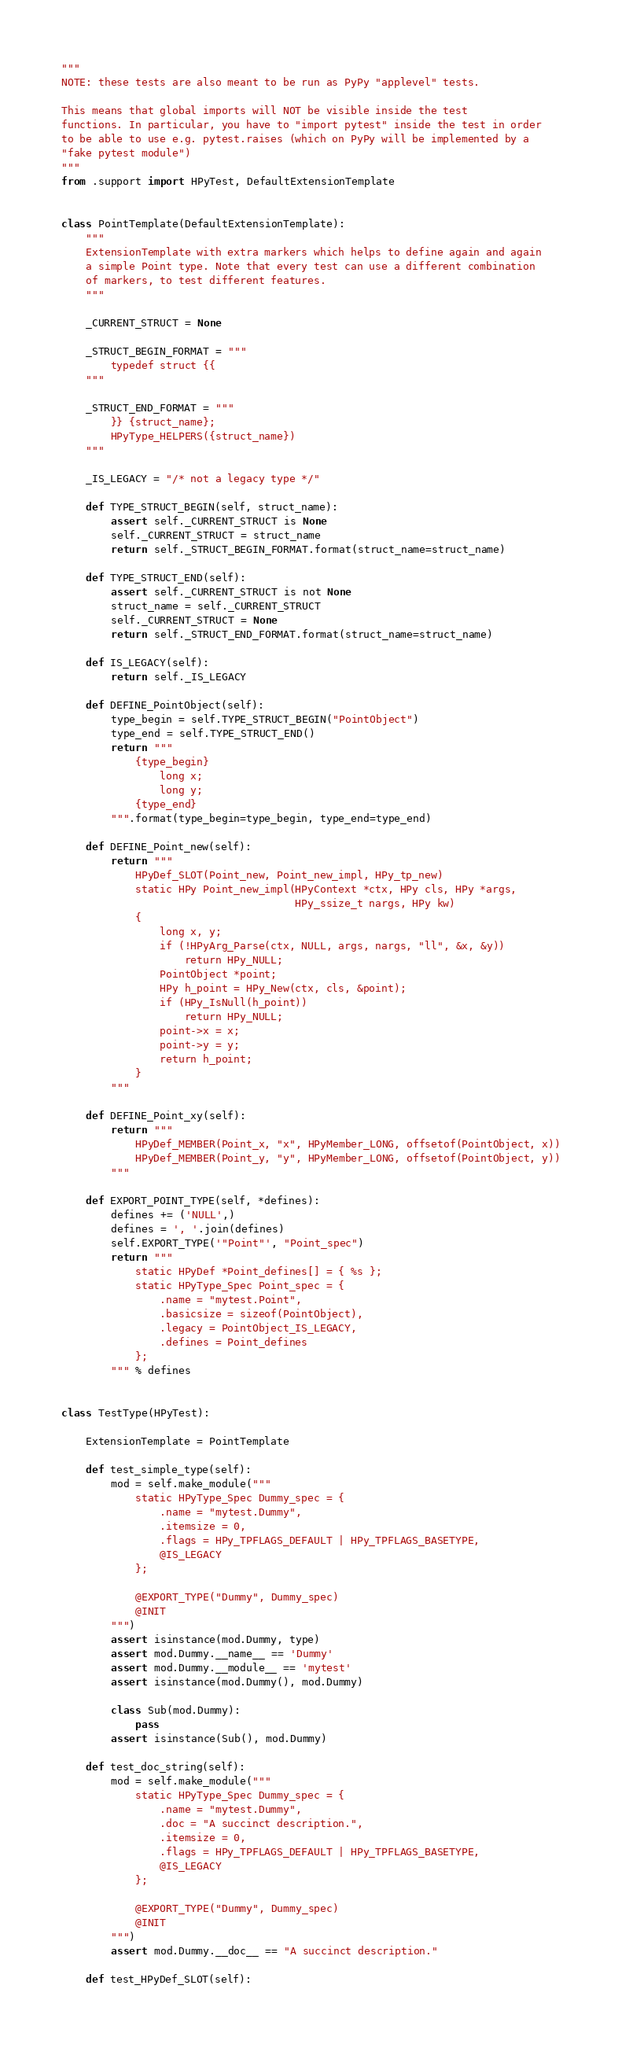Convert code to text. <code><loc_0><loc_0><loc_500><loc_500><_Python_>"""
NOTE: these tests are also meant to be run as PyPy "applevel" tests.

This means that global imports will NOT be visible inside the test
functions. In particular, you have to "import pytest" inside the test in order
to be able to use e.g. pytest.raises (which on PyPy will be implemented by a
"fake pytest module")
"""
from .support import HPyTest, DefaultExtensionTemplate


class PointTemplate(DefaultExtensionTemplate):
    """
    ExtensionTemplate with extra markers which helps to define again and again
    a simple Point type. Note that every test can use a different combination
    of markers, to test different features.
    """

    _CURRENT_STRUCT = None

    _STRUCT_BEGIN_FORMAT = """
        typedef struct {{
    """

    _STRUCT_END_FORMAT = """
        }} {struct_name};
        HPyType_HELPERS({struct_name})
    """

    _IS_LEGACY = "/* not a legacy type */"

    def TYPE_STRUCT_BEGIN(self, struct_name):
        assert self._CURRENT_STRUCT is None
        self._CURRENT_STRUCT = struct_name
        return self._STRUCT_BEGIN_FORMAT.format(struct_name=struct_name)

    def TYPE_STRUCT_END(self):
        assert self._CURRENT_STRUCT is not None
        struct_name = self._CURRENT_STRUCT
        self._CURRENT_STRUCT = None
        return self._STRUCT_END_FORMAT.format(struct_name=struct_name)

    def IS_LEGACY(self):
        return self._IS_LEGACY

    def DEFINE_PointObject(self):
        type_begin = self.TYPE_STRUCT_BEGIN("PointObject")
        type_end = self.TYPE_STRUCT_END()
        return """
            {type_begin}
                long x;
                long y;
            {type_end}
        """.format(type_begin=type_begin, type_end=type_end)

    def DEFINE_Point_new(self):
        return """
            HPyDef_SLOT(Point_new, Point_new_impl, HPy_tp_new)
            static HPy Point_new_impl(HPyContext *ctx, HPy cls, HPy *args,
                                      HPy_ssize_t nargs, HPy kw)
            {
                long x, y;
                if (!HPyArg_Parse(ctx, NULL, args, nargs, "ll", &x, &y))
                    return HPy_NULL;
                PointObject *point;
                HPy h_point = HPy_New(ctx, cls, &point);
                if (HPy_IsNull(h_point))
                    return HPy_NULL;
                point->x = x;
                point->y = y;
                return h_point;
            }
        """

    def DEFINE_Point_xy(self):
        return """
            HPyDef_MEMBER(Point_x, "x", HPyMember_LONG, offsetof(PointObject, x))
            HPyDef_MEMBER(Point_y, "y", HPyMember_LONG, offsetof(PointObject, y))
        """

    def EXPORT_POINT_TYPE(self, *defines):
        defines += ('NULL',)
        defines = ', '.join(defines)
        self.EXPORT_TYPE('"Point"', "Point_spec")
        return """
            static HPyDef *Point_defines[] = { %s };
            static HPyType_Spec Point_spec = {
                .name = "mytest.Point",
                .basicsize = sizeof(PointObject),
                .legacy = PointObject_IS_LEGACY,
                .defines = Point_defines
            };
        """ % defines


class TestType(HPyTest):

    ExtensionTemplate = PointTemplate

    def test_simple_type(self):
        mod = self.make_module("""
            static HPyType_Spec Dummy_spec = {
                .name = "mytest.Dummy",
                .itemsize = 0,
                .flags = HPy_TPFLAGS_DEFAULT | HPy_TPFLAGS_BASETYPE,
                @IS_LEGACY
            };

            @EXPORT_TYPE("Dummy", Dummy_spec)
            @INIT
        """)
        assert isinstance(mod.Dummy, type)
        assert mod.Dummy.__name__ == 'Dummy'
        assert mod.Dummy.__module__ == 'mytest'
        assert isinstance(mod.Dummy(), mod.Dummy)

        class Sub(mod.Dummy):
            pass
        assert isinstance(Sub(), mod.Dummy)

    def test_doc_string(self):
        mod = self.make_module("""
            static HPyType_Spec Dummy_spec = {
                .name = "mytest.Dummy",
                .doc = "A succinct description.",
                .itemsize = 0,
                .flags = HPy_TPFLAGS_DEFAULT | HPy_TPFLAGS_BASETYPE,
                @IS_LEGACY
            };

            @EXPORT_TYPE("Dummy", Dummy_spec)
            @INIT
        """)
        assert mod.Dummy.__doc__ == "A succinct description."

    def test_HPyDef_SLOT(self):</code> 